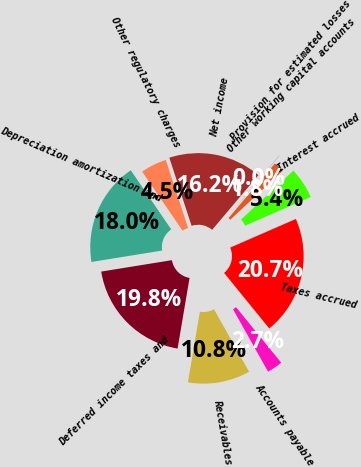<chart> <loc_0><loc_0><loc_500><loc_500><pie_chart><fcel>Net income<fcel>Other regulatory charges<fcel>Depreciation amortization and<fcel>Deferred income taxes and<fcel>Receivables<fcel>Accounts payable<fcel>Taxes accrued<fcel>Interest accrued<fcel>Other working capital accounts<fcel>Provision for estimated losses<nl><fcel>16.19%<fcel>4.53%<fcel>17.99%<fcel>19.78%<fcel>10.81%<fcel>2.73%<fcel>20.68%<fcel>5.42%<fcel>1.83%<fcel>0.04%<nl></chart> 